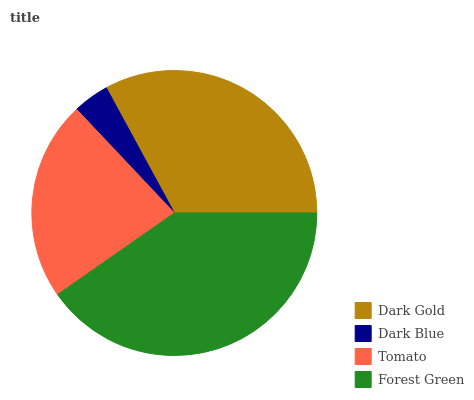Is Dark Blue the minimum?
Answer yes or no. Yes. Is Forest Green the maximum?
Answer yes or no. Yes. Is Tomato the minimum?
Answer yes or no. No. Is Tomato the maximum?
Answer yes or no. No. Is Tomato greater than Dark Blue?
Answer yes or no. Yes. Is Dark Blue less than Tomato?
Answer yes or no. Yes. Is Dark Blue greater than Tomato?
Answer yes or no. No. Is Tomato less than Dark Blue?
Answer yes or no. No. Is Dark Gold the high median?
Answer yes or no. Yes. Is Tomato the low median?
Answer yes or no. Yes. Is Tomato the high median?
Answer yes or no. No. Is Forest Green the low median?
Answer yes or no. No. 